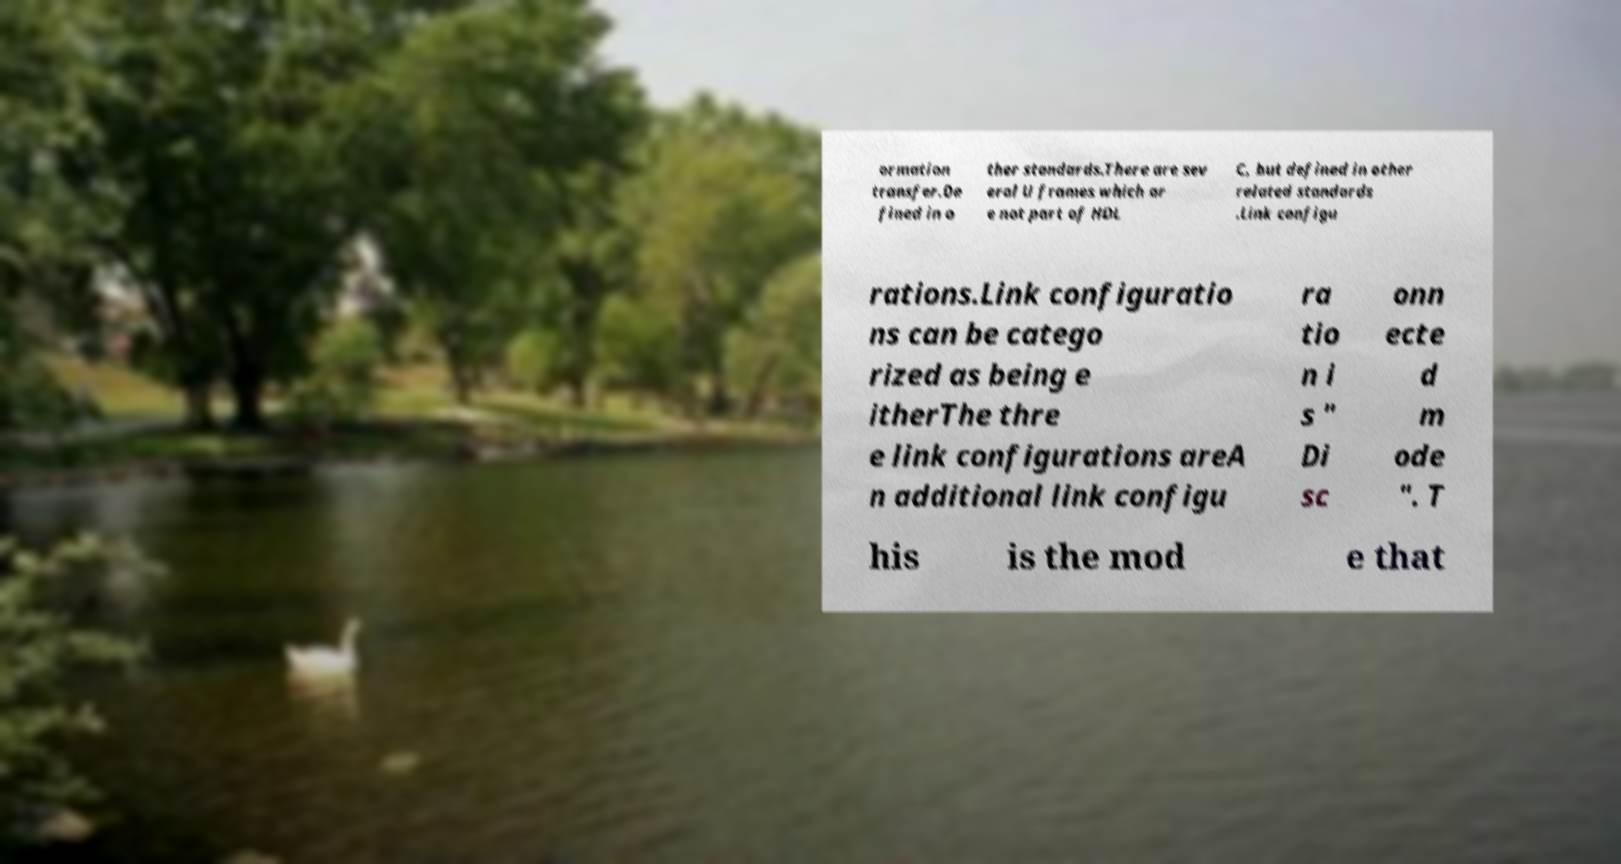Please read and relay the text visible in this image. What does it say? ormation transfer.De fined in o ther standards.There are sev eral U frames which ar e not part of HDL C, but defined in other related standards .Link configu rations.Link configuratio ns can be catego rized as being e itherThe thre e link configurations areA n additional link configu ra tio n i s " Di sc onn ecte d m ode ". T his is the mod e that 